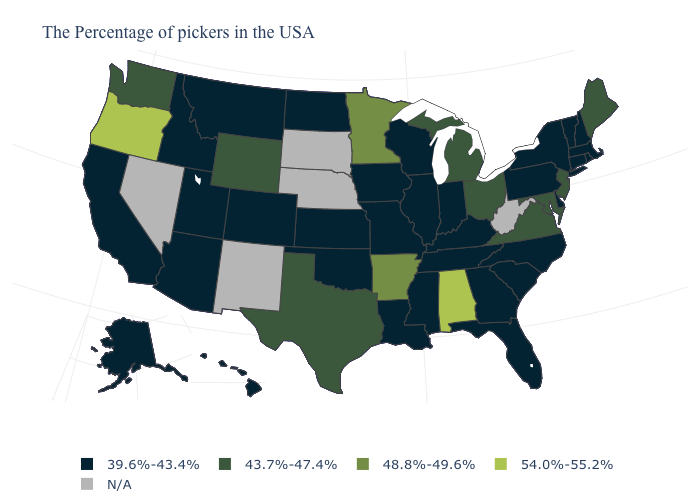What is the highest value in the USA?
Be succinct. 54.0%-55.2%. Among the states that border Maine , which have the highest value?
Answer briefly. New Hampshire. What is the lowest value in the USA?
Concise answer only. 39.6%-43.4%. What is the value of Kansas?
Keep it brief. 39.6%-43.4%. How many symbols are there in the legend?
Quick response, please. 5. What is the value of Kansas?
Answer briefly. 39.6%-43.4%. Which states have the highest value in the USA?
Be succinct. Alabama, Oregon. Name the states that have a value in the range 39.6%-43.4%?
Short answer required. Massachusetts, Rhode Island, New Hampshire, Vermont, Connecticut, New York, Delaware, Pennsylvania, North Carolina, South Carolina, Florida, Georgia, Kentucky, Indiana, Tennessee, Wisconsin, Illinois, Mississippi, Louisiana, Missouri, Iowa, Kansas, Oklahoma, North Dakota, Colorado, Utah, Montana, Arizona, Idaho, California, Alaska, Hawaii. Name the states that have a value in the range N/A?
Write a very short answer. West Virginia, Nebraska, South Dakota, New Mexico, Nevada. Name the states that have a value in the range 48.8%-49.6%?
Short answer required. Arkansas, Minnesota. Name the states that have a value in the range 54.0%-55.2%?
Quick response, please. Alabama, Oregon. Name the states that have a value in the range N/A?
Answer briefly. West Virginia, Nebraska, South Dakota, New Mexico, Nevada. Which states have the highest value in the USA?
Be succinct. Alabama, Oregon. What is the lowest value in the West?
Keep it brief. 39.6%-43.4%. 